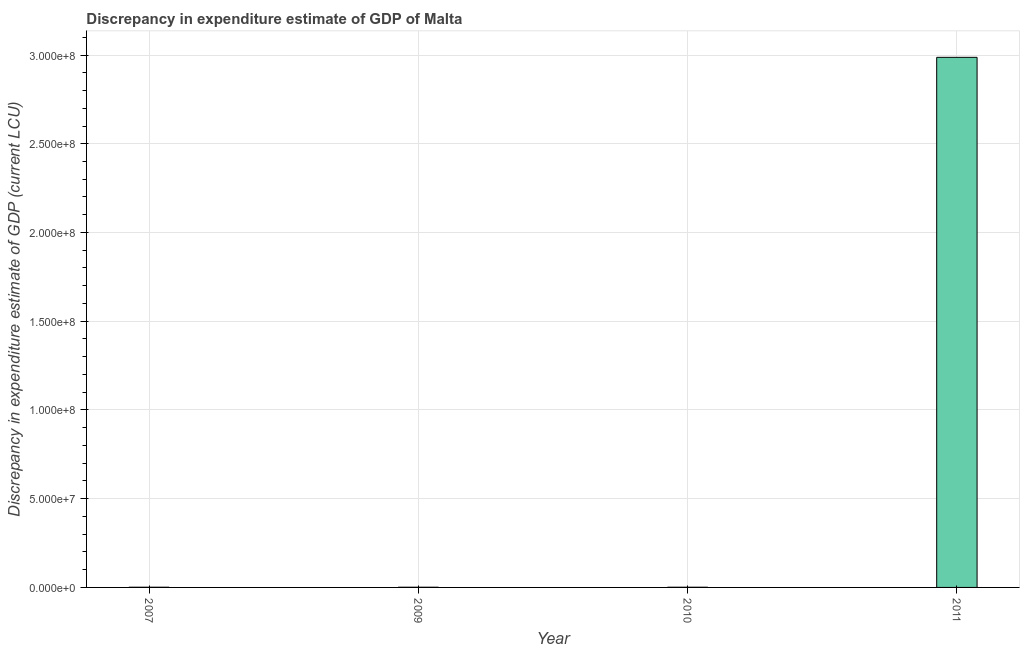Does the graph contain any zero values?
Your answer should be compact. No. Does the graph contain grids?
Provide a succinct answer. Yes. What is the title of the graph?
Your response must be concise. Discrepancy in expenditure estimate of GDP of Malta. What is the label or title of the Y-axis?
Provide a short and direct response. Discrepancy in expenditure estimate of GDP (current LCU). What is the discrepancy in expenditure estimate of gdp in 2007?
Offer a very short reply. 1.00e+05. Across all years, what is the maximum discrepancy in expenditure estimate of gdp?
Keep it short and to the point. 2.99e+08. In which year was the discrepancy in expenditure estimate of gdp maximum?
Your answer should be very brief. 2011. In which year was the discrepancy in expenditure estimate of gdp minimum?
Your answer should be compact. 2007. What is the sum of the discrepancy in expenditure estimate of gdp?
Give a very brief answer. 2.99e+08. What is the difference between the discrepancy in expenditure estimate of gdp in 2010 and 2011?
Offer a terse response. -2.99e+08. What is the average discrepancy in expenditure estimate of gdp per year?
Offer a very short reply. 7.48e+07. Do a majority of the years between 2011 and 2007 (inclusive) have discrepancy in expenditure estimate of gdp greater than 70000000 LCU?
Offer a terse response. Yes. Is the discrepancy in expenditure estimate of gdp in 2007 less than that in 2010?
Keep it short and to the point. No. Is the difference between the discrepancy in expenditure estimate of gdp in 2010 and 2011 greater than the difference between any two years?
Offer a very short reply. Yes. What is the difference between the highest and the second highest discrepancy in expenditure estimate of gdp?
Your response must be concise. 2.99e+08. What is the difference between the highest and the lowest discrepancy in expenditure estimate of gdp?
Provide a succinct answer. 2.99e+08. In how many years, is the discrepancy in expenditure estimate of gdp greater than the average discrepancy in expenditure estimate of gdp taken over all years?
Offer a very short reply. 1. How many bars are there?
Give a very brief answer. 4. What is the Discrepancy in expenditure estimate of GDP (current LCU) in 2007?
Your answer should be very brief. 1.00e+05. What is the Discrepancy in expenditure estimate of GDP (current LCU) in 2009?
Your answer should be very brief. 1.00e+05. What is the Discrepancy in expenditure estimate of GDP (current LCU) in 2010?
Ensure brevity in your answer.  1.00e+05. What is the Discrepancy in expenditure estimate of GDP (current LCU) in 2011?
Make the answer very short. 2.99e+08. What is the difference between the Discrepancy in expenditure estimate of GDP (current LCU) in 2007 and 2010?
Give a very brief answer. 0. What is the difference between the Discrepancy in expenditure estimate of GDP (current LCU) in 2007 and 2011?
Your answer should be compact. -2.99e+08. What is the difference between the Discrepancy in expenditure estimate of GDP (current LCU) in 2009 and 2010?
Offer a very short reply. 0. What is the difference between the Discrepancy in expenditure estimate of GDP (current LCU) in 2009 and 2011?
Offer a very short reply. -2.99e+08. What is the difference between the Discrepancy in expenditure estimate of GDP (current LCU) in 2010 and 2011?
Your answer should be compact. -2.99e+08. What is the ratio of the Discrepancy in expenditure estimate of GDP (current LCU) in 2007 to that in 2009?
Provide a succinct answer. 1. What is the ratio of the Discrepancy in expenditure estimate of GDP (current LCU) in 2007 to that in 2010?
Provide a short and direct response. 1. What is the ratio of the Discrepancy in expenditure estimate of GDP (current LCU) in 2007 to that in 2011?
Provide a succinct answer. 0. What is the ratio of the Discrepancy in expenditure estimate of GDP (current LCU) in 2009 to that in 2010?
Provide a succinct answer. 1. What is the ratio of the Discrepancy in expenditure estimate of GDP (current LCU) in 2010 to that in 2011?
Provide a succinct answer. 0. 